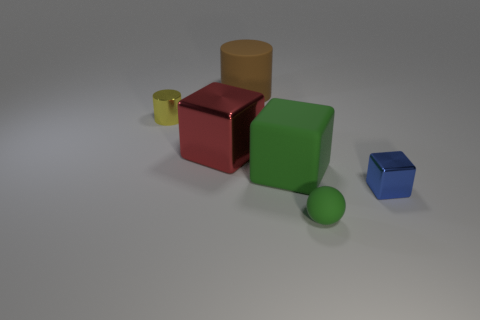Are there any other things that are the same shape as the small green thing?
Make the answer very short. No. How many large matte things have the same shape as the large red shiny thing?
Offer a terse response. 1. What size is the red cube that is made of the same material as the tiny yellow cylinder?
Your answer should be compact. Large. What is the material of the object that is both in front of the big red block and left of the tiny green matte sphere?
Your answer should be very brief. Rubber. What number of other spheres have the same size as the sphere?
Your answer should be very brief. 0. What is the material of the red object that is the same shape as the tiny blue metal object?
Ensure brevity in your answer.  Metal. What number of things are blocks right of the brown cylinder or small objects right of the big brown object?
Offer a terse response. 3. Is the shape of the tiny yellow object the same as the large object on the right side of the big brown thing?
Your response must be concise. No. What shape is the tiny metal object that is right of the matte thing that is to the left of the green rubber thing that is behind the tiny matte object?
Keep it short and to the point. Cube. How many other things are there of the same material as the red thing?
Your answer should be compact. 2. 